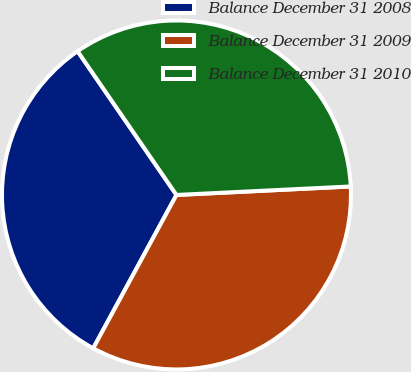Convert chart. <chart><loc_0><loc_0><loc_500><loc_500><pie_chart><fcel>Balance December 31 2008<fcel>Balance December 31 2009<fcel>Balance December 31 2010<nl><fcel>32.49%<fcel>33.69%<fcel>33.81%<nl></chart> 